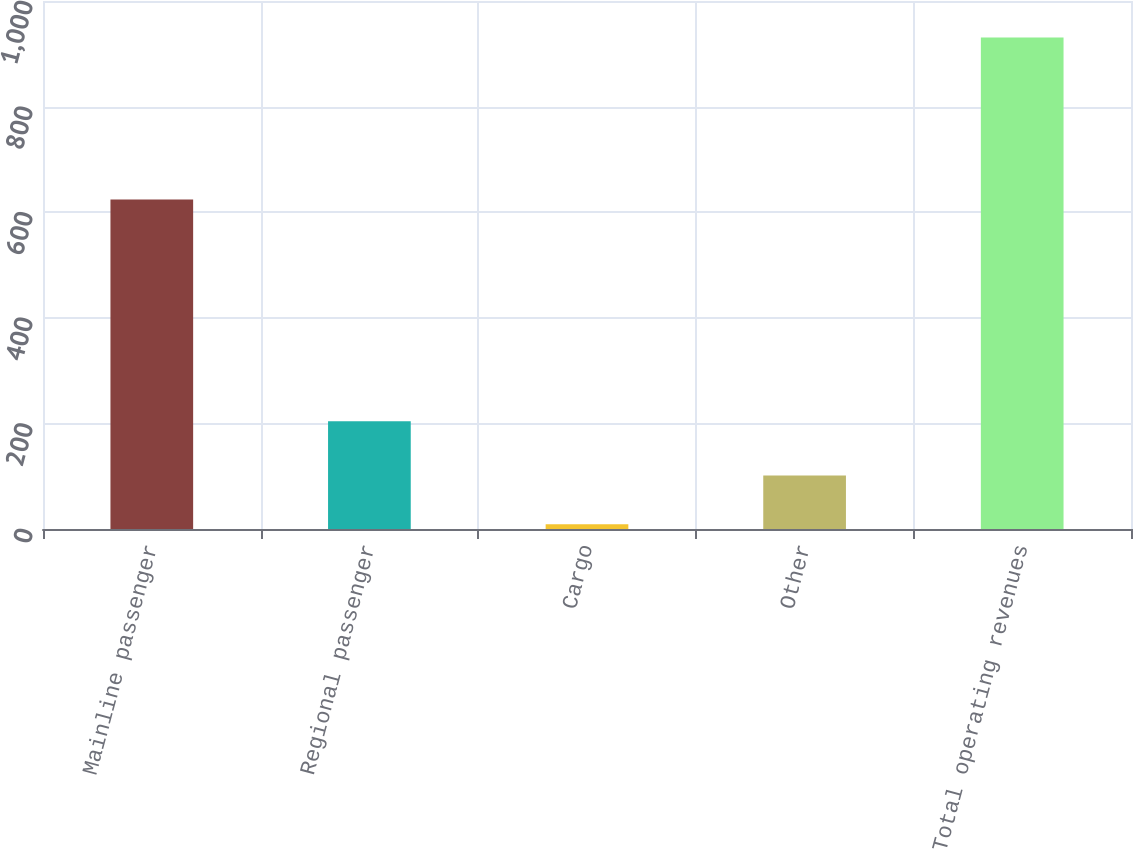Convert chart. <chart><loc_0><loc_0><loc_500><loc_500><bar_chart><fcel>Mainline passenger<fcel>Regional passenger<fcel>Cargo<fcel>Other<fcel>Total operating revenues<nl><fcel>624<fcel>204<fcel>9<fcel>101.2<fcel>931<nl></chart> 